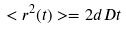<formula> <loc_0><loc_0><loc_500><loc_500>< r ^ { 2 } ( t ) > = 2 d D t</formula> 